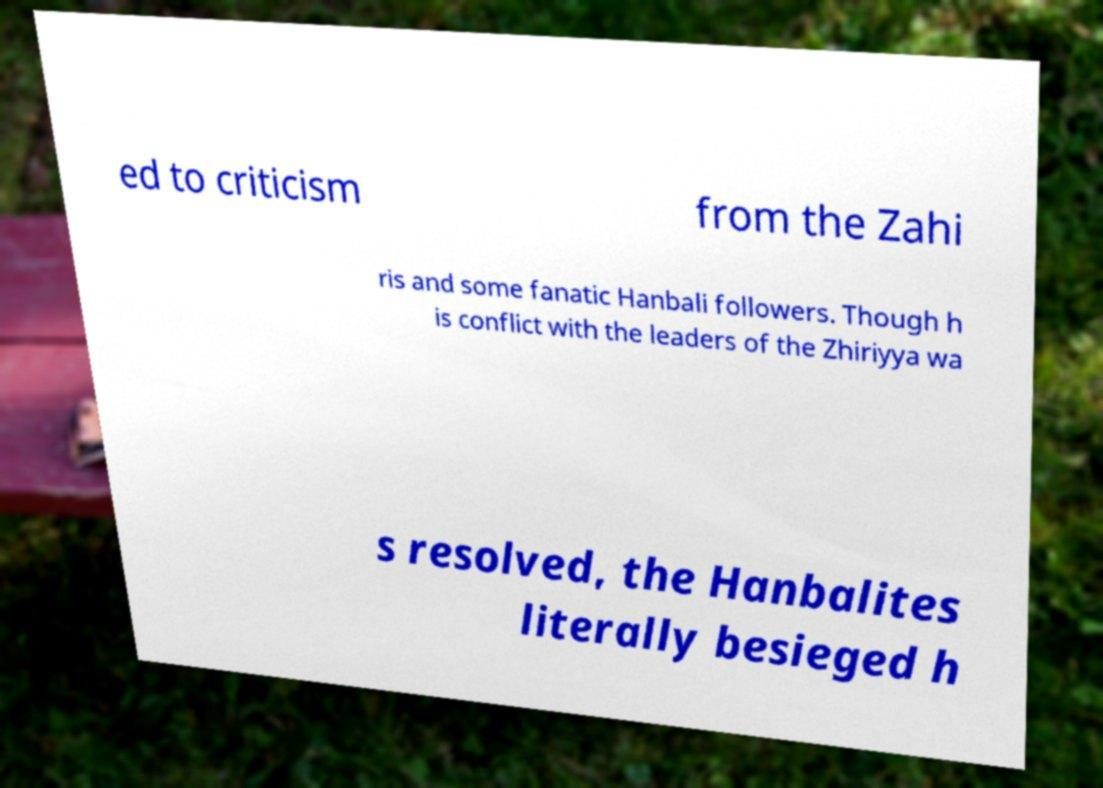Please identify and transcribe the text found in this image. ed to criticism from the Zahi ris and some fanatic Hanbali followers. Though h is conflict with the leaders of the Zhiriyya wa s resolved, the Hanbalites literally besieged h 